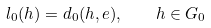<formula> <loc_0><loc_0><loc_500><loc_500>l _ { 0 } ( h ) = d _ { 0 } ( h , e ) , \quad h \in G _ { 0 }</formula> 